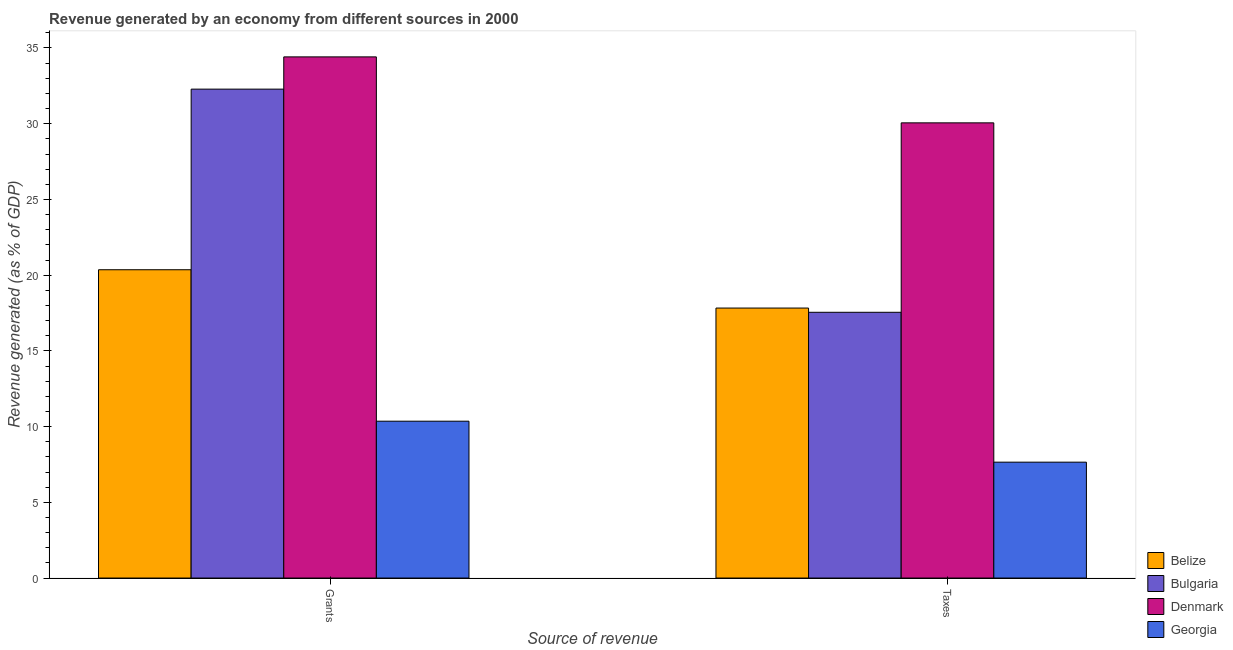How many different coloured bars are there?
Provide a succinct answer. 4. How many groups of bars are there?
Ensure brevity in your answer.  2. Are the number of bars per tick equal to the number of legend labels?
Keep it short and to the point. Yes. Are the number of bars on each tick of the X-axis equal?
Make the answer very short. Yes. How many bars are there on the 2nd tick from the right?
Provide a short and direct response. 4. What is the label of the 1st group of bars from the left?
Your answer should be very brief. Grants. What is the revenue generated by grants in Georgia?
Your response must be concise. 10.36. Across all countries, what is the maximum revenue generated by taxes?
Make the answer very short. 30.06. Across all countries, what is the minimum revenue generated by grants?
Provide a short and direct response. 10.36. In which country was the revenue generated by grants minimum?
Give a very brief answer. Georgia. What is the total revenue generated by taxes in the graph?
Provide a short and direct response. 73.08. What is the difference between the revenue generated by taxes in Bulgaria and that in Georgia?
Ensure brevity in your answer.  9.9. What is the difference between the revenue generated by grants in Bulgaria and the revenue generated by taxes in Georgia?
Your answer should be compact. 24.63. What is the average revenue generated by grants per country?
Provide a succinct answer. 24.35. What is the difference between the revenue generated by taxes and revenue generated by grants in Georgia?
Ensure brevity in your answer.  -2.71. In how many countries, is the revenue generated by taxes greater than 1 %?
Your response must be concise. 4. What is the ratio of the revenue generated by grants in Denmark to that in Belize?
Your answer should be compact. 1.69. Is the revenue generated by grants in Bulgaria less than that in Denmark?
Your answer should be very brief. Yes. What does the 1st bar from the left in Grants represents?
Offer a terse response. Belize. What does the 3rd bar from the right in Grants represents?
Your answer should be very brief. Bulgaria. How are the legend labels stacked?
Offer a terse response. Vertical. What is the title of the graph?
Give a very brief answer. Revenue generated by an economy from different sources in 2000. Does "Pacific island small states" appear as one of the legend labels in the graph?
Your answer should be very brief. No. What is the label or title of the X-axis?
Offer a terse response. Source of revenue. What is the label or title of the Y-axis?
Provide a short and direct response. Revenue generated (as % of GDP). What is the Revenue generated (as % of GDP) of Belize in Grants?
Offer a very short reply. 20.36. What is the Revenue generated (as % of GDP) in Bulgaria in Grants?
Ensure brevity in your answer.  32.28. What is the Revenue generated (as % of GDP) of Denmark in Grants?
Your answer should be very brief. 34.41. What is the Revenue generated (as % of GDP) in Georgia in Grants?
Your answer should be very brief. 10.36. What is the Revenue generated (as % of GDP) in Belize in Taxes?
Offer a terse response. 17.83. What is the Revenue generated (as % of GDP) of Bulgaria in Taxes?
Provide a succinct answer. 17.55. What is the Revenue generated (as % of GDP) in Denmark in Taxes?
Give a very brief answer. 30.06. What is the Revenue generated (as % of GDP) of Georgia in Taxes?
Offer a very short reply. 7.65. Across all Source of revenue, what is the maximum Revenue generated (as % of GDP) in Belize?
Provide a succinct answer. 20.36. Across all Source of revenue, what is the maximum Revenue generated (as % of GDP) in Bulgaria?
Provide a short and direct response. 32.28. Across all Source of revenue, what is the maximum Revenue generated (as % of GDP) of Denmark?
Offer a very short reply. 34.41. Across all Source of revenue, what is the maximum Revenue generated (as % of GDP) in Georgia?
Your answer should be very brief. 10.36. Across all Source of revenue, what is the minimum Revenue generated (as % of GDP) of Belize?
Your answer should be very brief. 17.83. Across all Source of revenue, what is the minimum Revenue generated (as % of GDP) of Bulgaria?
Offer a very short reply. 17.55. Across all Source of revenue, what is the minimum Revenue generated (as % of GDP) of Denmark?
Provide a succinct answer. 30.06. Across all Source of revenue, what is the minimum Revenue generated (as % of GDP) in Georgia?
Keep it short and to the point. 7.65. What is the total Revenue generated (as % of GDP) of Belize in the graph?
Your answer should be compact. 38.19. What is the total Revenue generated (as % of GDP) in Bulgaria in the graph?
Your response must be concise. 49.83. What is the total Revenue generated (as % of GDP) of Denmark in the graph?
Your answer should be very brief. 64.47. What is the total Revenue generated (as % of GDP) in Georgia in the graph?
Offer a very short reply. 18.01. What is the difference between the Revenue generated (as % of GDP) of Belize in Grants and that in Taxes?
Keep it short and to the point. 2.53. What is the difference between the Revenue generated (as % of GDP) of Bulgaria in Grants and that in Taxes?
Keep it short and to the point. 14.74. What is the difference between the Revenue generated (as % of GDP) of Denmark in Grants and that in Taxes?
Offer a very short reply. 4.36. What is the difference between the Revenue generated (as % of GDP) in Georgia in Grants and that in Taxes?
Ensure brevity in your answer.  2.71. What is the difference between the Revenue generated (as % of GDP) of Belize in Grants and the Revenue generated (as % of GDP) of Bulgaria in Taxes?
Ensure brevity in your answer.  2.81. What is the difference between the Revenue generated (as % of GDP) in Belize in Grants and the Revenue generated (as % of GDP) in Denmark in Taxes?
Offer a terse response. -9.7. What is the difference between the Revenue generated (as % of GDP) of Belize in Grants and the Revenue generated (as % of GDP) of Georgia in Taxes?
Give a very brief answer. 12.71. What is the difference between the Revenue generated (as % of GDP) of Bulgaria in Grants and the Revenue generated (as % of GDP) of Denmark in Taxes?
Keep it short and to the point. 2.23. What is the difference between the Revenue generated (as % of GDP) in Bulgaria in Grants and the Revenue generated (as % of GDP) in Georgia in Taxes?
Your answer should be very brief. 24.63. What is the difference between the Revenue generated (as % of GDP) in Denmark in Grants and the Revenue generated (as % of GDP) in Georgia in Taxes?
Your answer should be very brief. 26.76. What is the average Revenue generated (as % of GDP) of Belize per Source of revenue?
Your response must be concise. 19.09. What is the average Revenue generated (as % of GDP) in Bulgaria per Source of revenue?
Provide a short and direct response. 24.92. What is the average Revenue generated (as % of GDP) in Denmark per Source of revenue?
Offer a terse response. 32.24. What is the average Revenue generated (as % of GDP) of Georgia per Source of revenue?
Your answer should be very brief. 9. What is the difference between the Revenue generated (as % of GDP) in Belize and Revenue generated (as % of GDP) in Bulgaria in Grants?
Provide a succinct answer. -11.93. What is the difference between the Revenue generated (as % of GDP) of Belize and Revenue generated (as % of GDP) of Denmark in Grants?
Your answer should be compact. -14.06. What is the difference between the Revenue generated (as % of GDP) of Belize and Revenue generated (as % of GDP) of Georgia in Grants?
Make the answer very short. 10. What is the difference between the Revenue generated (as % of GDP) of Bulgaria and Revenue generated (as % of GDP) of Denmark in Grants?
Make the answer very short. -2.13. What is the difference between the Revenue generated (as % of GDP) of Bulgaria and Revenue generated (as % of GDP) of Georgia in Grants?
Offer a very short reply. 21.93. What is the difference between the Revenue generated (as % of GDP) in Denmark and Revenue generated (as % of GDP) in Georgia in Grants?
Give a very brief answer. 24.06. What is the difference between the Revenue generated (as % of GDP) in Belize and Revenue generated (as % of GDP) in Bulgaria in Taxes?
Your response must be concise. 0.28. What is the difference between the Revenue generated (as % of GDP) in Belize and Revenue generated (as % of GDP) in Denmark in Taxes?
Offer a terse response. -12.23. What is the difference between the Revenue generated (as % of GDP) of Belize and Revenue generated (as % of GDP) of Georgia in Taxes?
Your answer should be compact. 10.18. What is the difference between the Revenue generated (as % of GDP) in Bulgaria and Revenue generated (as % of GDP) in Denmark in Taxes?
Your answer should be compact. -12.51. What is the difference between the Revenue generated (as % of GDP) of Bulgaria and Revenue generated (as % of GDP) of Georgia in Taxes?
Offer a terse response. 9.9. What is the difference between the Revenue generated (as % of GDP) of Denmark and Revenue generated (as % of GDP) of Georgia in Taxes?
Ensure brevity in your answer.  22.41. What is the ratio of the Revenue generated (as % of GDP) in Belize in Grants to that in Taxes?
Give a very brief answer. 1.14. What is the ratio of the Revenue generated (as % of GDP) in Bulgaria in Grants to that in Taxes?
Your response must be concise. 1.84. What is the ratio of the Revenue generated (as % of GDP) of Denmark in Grants to that in Taxes?
Your answer should be compact. 1.14. What is the ratio of the Revenue generated (as % of GDP) of Georgia in Grants to that in Taxes?
Provide a short and direct response. 1.35. What is the difference between the highest and the second highest Revenue generated (as % of GDP) in Belize?
Make the answer very short. 2.53. What is the difference between the highest and the second highest Revenue generated (as % of GDP) of Bulgaria?
Your response must be concise. 14.74. What is the difference between the highest and the second highest Revenue generated (as % of GDP) in Denmark?
Ensure brevity in your answer.  4.36. What is the difference between the highest and the second highest Revenue generated (as % of GDP) in Georgia?
Offer a terse response. 2.71. What is the difference between the highest and the lowest Revenue generated (as % of GDP) in Belize?
Give a very brief answer. 2.53. What is the difference between the highest and the lowest Revenue generated (as % of GDP) of Bulgaria?
Your answer should be very brief. 14.74. What is the difference between the highest and the lowest Revenue generated (as % of GDP) of Denmark?
Give a very brief answer. 4.36. What is the difference between the highest and the lowest Revenue generated (as % of GDP) in Georgia?
Provide a succinct answer. 2.71. 